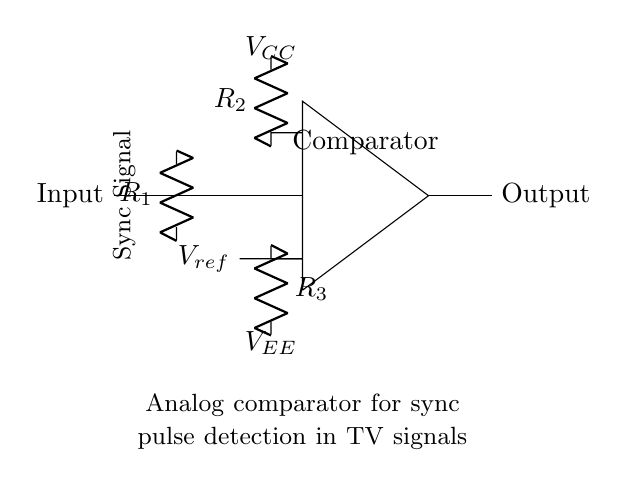What is the type of circuit diagram shown? The diagram depicts an analog comparator circuit, which is designed to compare input signals against a reference voltage.
Answer: analog comparator What are the values of the resistors labeled in the circuit? The circuit includes three resistors labeled R1, R2, and R3, but their specific values are not provided in the diagram. Typically, these would be included in a more detailed schematic or accompanying documentation.
Answer: not provided What does the node marked "Vref" represent? The "Vref" node is the reference voltage against which the input signal will be compared in the circuit to determine output changes.
Answer: reference voltage What are the two power supplies connected to the comparator? The two power supplies connected to the comparator are denoted as VCC for the positive supply and VEE for the negative supply, providing the necessary operating voltages for the comparator.
Answer: VCC and VEE What is the main function of the output in this circuit? The output of the comparator indicates whether the input signal exceeds the reference voltage, thereby detecting the presence of sync pulses from television signals.
Answer: sync pulse detection How does the comparator determine the output state? The comparator compares the input voltage from the sync signal against the reference voltage (Vref) and produces a high (1) or low (0) output based on whether the input signal is greater or less than the reference voltage, respectively.
Answer: high or low output What role does resistor R1 play in the circuit? Resistor R1 likely serves as a current limiting or voltage dividing element for the input signal, helping to set the appropriate input level at the comparator's non-inverting terminal.
Answer: current limiting or voltage dividing 